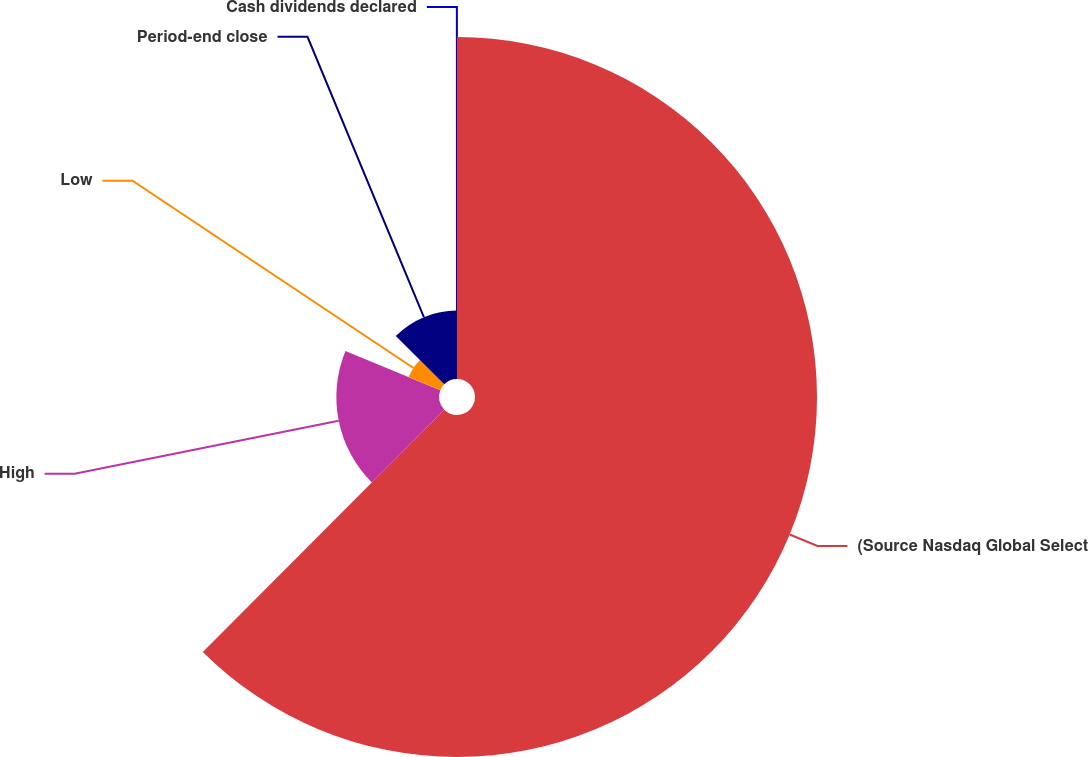Convert chart to OTSL. <chart><loc_0><loc_0><loc_500><loc_500><pie_chart><fcel>(Source Nasdaq Global Select<fcel>High<fcel>Low<fcel>Period-end close<fcel>Cash dividends declared<nl><fcel>62.47%<fcel>18.75%<fcel>6.26%<fcel>12.5%<fcel>0.01%<nl></chart> 